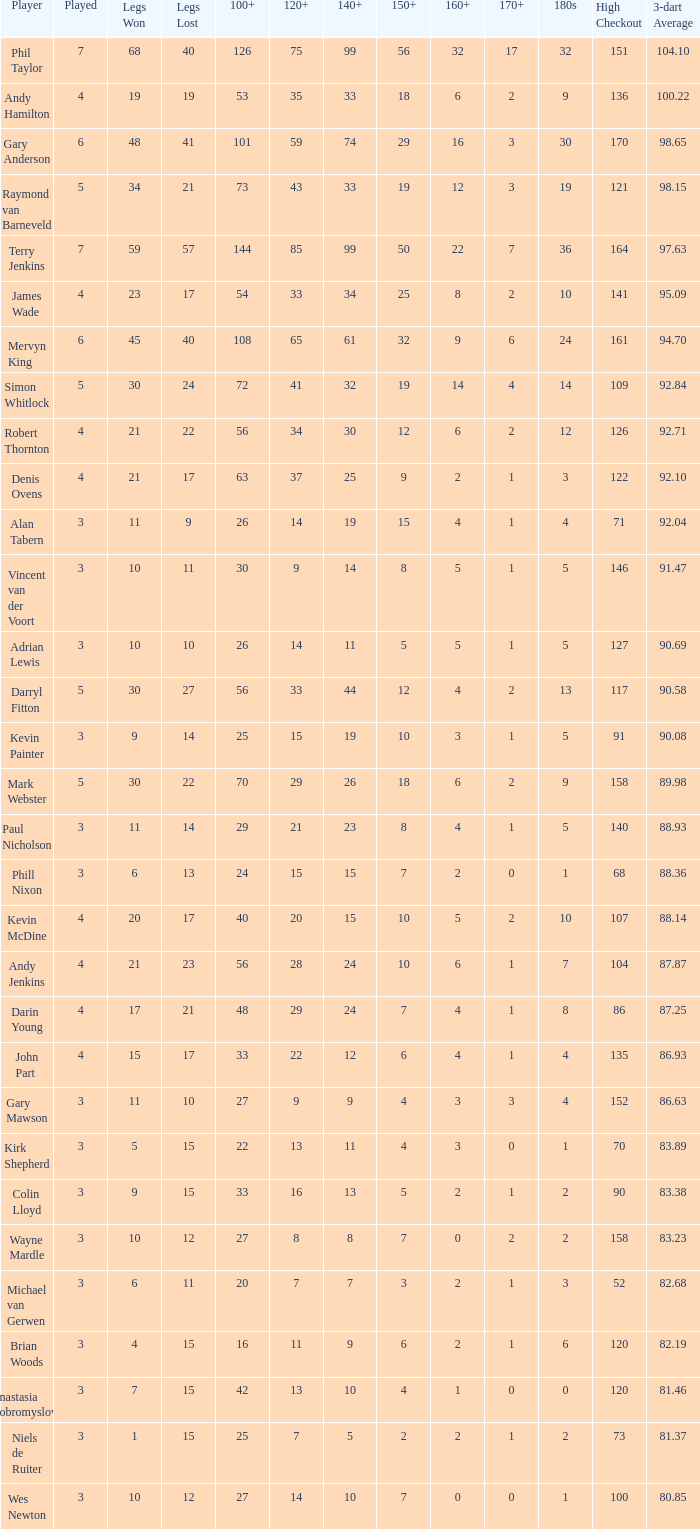What is the most legs lost of all? 57.0. 